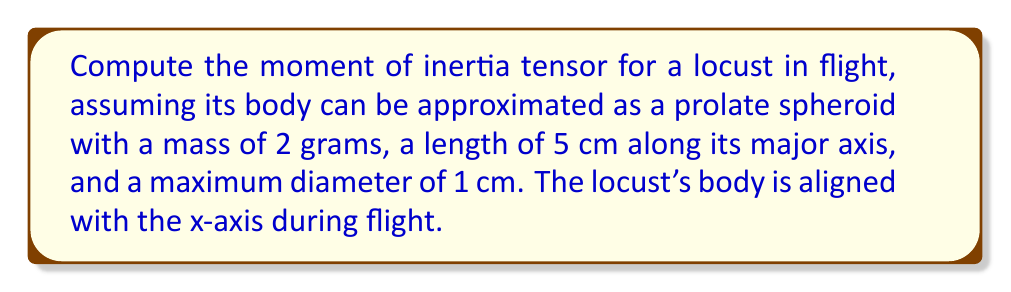Solve this math problem. To solve this problem, we'll follow these steps:

1) For a prolate spheroid aligned with the x-axis, the moment of inertia tensor is diagonal with components:

   $$I_{xx} = \frac{1}{5}m(b^2 + c^2)$$
   $$I_{yy} = I_{zz} = \frac{1}{5}m(a^2 + c^2)$$

   Where $m$ is the mass, $a$ is half the length of the major axis, and $b = c$ are the radii of the minor axes.

2) Given:
   - Mass $m = 2$ g = $2 \times 10^{-3}$ kg
   - Length = 5 cm, so $a = 2.5$ cm = $2.5 \times 10^{-2}$ m
   - Diameter = 1 cm, so $b = c = 0.5$ cm = $0.5 \times 10^{-2}$ m

3) Calculate $I_{xx}$:
   $$I_{xx} = \frac{1}{5} \times 2 \times 10^{-3} \times ((0.5 \times 10^{-2})^2 + (0.5 \times 10^{-2})^2)$$
   $$I_{xx} = 1 \times 10^{-9} \text{ kg}\cdot\text{m}^2$$

4) Calculate $I_{yy}$ and $I_{zz}$:
   $$I_{yy} = I_{zz} = \frac{1}{5} \times 2 \times 10^{-3} \times ((2.5 \times 10^{-2})^2 + (0.5 \times 10^{-2})^2)$$
   $$I_{yy} = I_{zz} = 2.6 \times 10^{-8} \text{ kg}\cdot\text{m}^2$$

5) The moment of inertia tensor is:

   $$I = \begin{bmatrix}
   I_{xx} & 0 & 0 \\
   0 & I_{yy} & 0 \\
   0 & 0 & I_{zz}
   \end{bmatrix}$$

   $$I = \begin{bmatrix}
   1 \times 10^{-9} & 0 & 0 \\
   0 & 2.6 \times 10^{-8} & 0 \\
   0 & 0 & 2.6 \times 10^{-8}
   \end{bmatrix} \text{ kg}\cdot\text{m}^2$$
Answer: $$I = \begin{bmatrix}
1 \times 10^{-9} & 0 & 0 \\
0 & 2.6 \times 10^{-8} & 0 \\
0 & 0 & 2.6 \times 10^{-8}
\end{bmatrix} \text{ kg}\cdot\text{m}^2$$ 